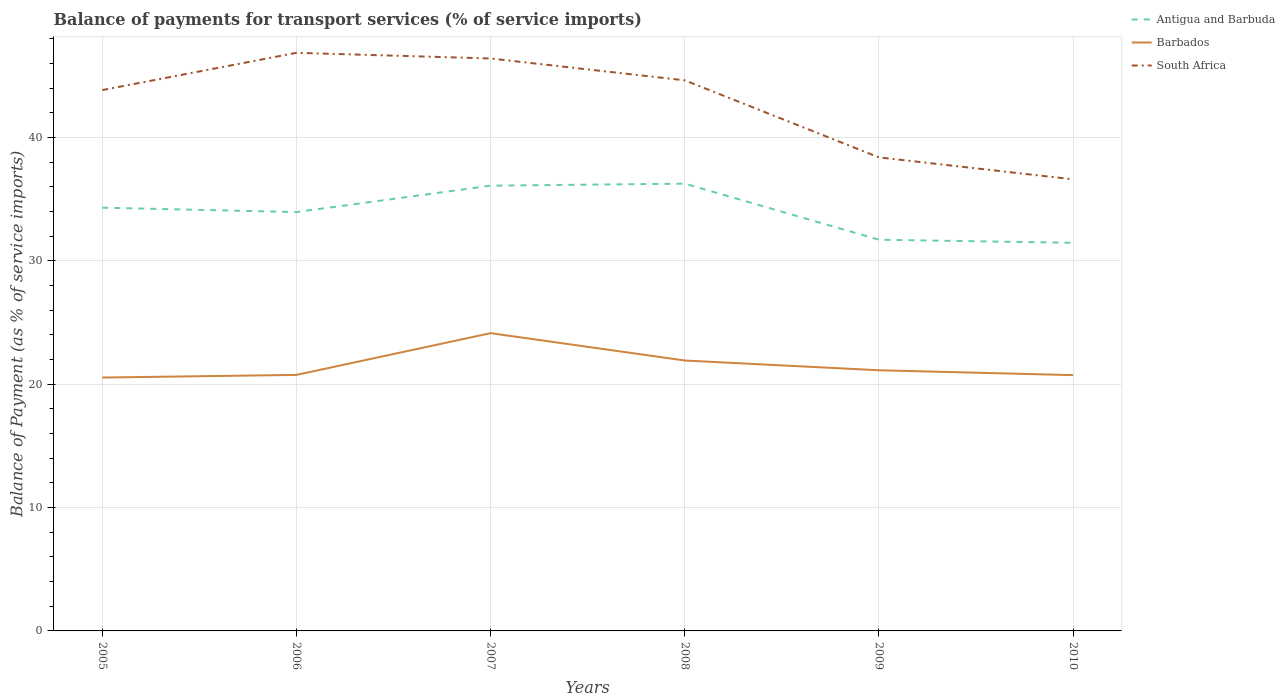Does the line corresponding to Barbados intersect with the line corresponding to South Africa?
Your answer should be compact. No. Across all years, what is the maximum balance of payments for transport services in Antigua and Barbuda?
Provide a succinct answer. 31.47. In which year was the balance of payments for transport services in Antigua and Barbuda maximum?
Your answer should be compact. 2010. What is the total balance of payments for transport services in Antigua and Barbuda in the graph?
Keep it short and to the point. -0.16. What is the difference between the highest and the second highest balance of payments for transport services in Antigua and Barbuda?
Your response must be concise. 4.8. What is the difference between the highest and the lowest balance of payments for transport services in South Africa?
Offer a terse response. 4. Are the values on the major ticks of Y-axis written in scientific E-notation?
Give a very brief answer. No. Does the graph contain grids?
Your answer should be very brief. Yes. Where does the legend appear in the graph?
Offer a terse response. Top right. How many legend labels are there?
Offer a terse response. 3. What is the title of the graph?
Your answer should be compact. Balance of payments for transport services (% of service imports). What is the label or title of the X-axis?
Your answer should be very brief. Years. What is the label or title of the Y-axis?
Offer a very short reply. Balance of Payment (as % of service imports). What is the Balance of Payment (as % of service imports) in Antigua and Barbuda in 2005?
Keep it short and to the point. 34.32. What is the Balance of Payment (as % of service imports) in Barbados in 2005?
Keep it short and to the point. 20.54. What is the Balance of Payment (as % of service imports) in South Africa in 2005?
Provide a short and direct response. 43.85. What is the Balance of Payment (as % of service imports) in Antigua and Barbuda in 2006?
Ensure brevity in your answer.  33.96. What is the Balance of Payment (as % of service imports) of Barbados in 2006?
Offer a very short reply. 20.76. What is the Balance of Payment (as % of service imports) in South Africa in 2006?
Your response must be concise. 46.87. What is the Balance of Payment (as % of service imports) of Antigua and Barbuda in 2007?
Your answer should be very brief. 36.1. What is the Balance of Payment (as % of service imports) of Barbados in 2007?
Make the answer very short. 24.14. What is the Balance of Payment (as % of service imports) in South Africa in 2007?
Make the answer very short. 46.41. What is the Balance of Payment (as % of service imports) in Antigua and Barbuda in 2008?
Your answer should be compact. 36.26. What is the Balance of Payment (as % of service imports) in Barbados in 2008?
Your response must be concise. 21.92. What is the Balance of Payment (as % of service imports) in South Africa in 2008?
Keep it short and to the point. 44.64. What is the Balance of Payment (as % of service imports) of Antigua and Barbuda in 2009?
Provide a succinct answer. 31.72. What is the Balance of Payment (as % of service imports) of Barbados in 2009?
Give a very brief answer. 21.13. What is the Balance of Payment (as % of service imports) in South Africa in 2009?
Give a very brief answer. 38.39. What is the Balance of Payment (as % of service imports) in Antigua and Barbuda in 2010?
Make the answer very short. 31.47. What is the Balance of Payment (as % of service imports) in Barbados in 2010?
Provide a short and direct response. 20.74. What is the Balance of Payment (as % of service imports) in South Africa in 2010?
Give a very brief answer. 36.61. Across all years, what is the maximum Balance of Payment (as % of service imports) of Antigua and Barbuda?
Keep it short and to the point. 36.26. Across all years, what is the maximum Balance of Payment (as % of service imports) of Barbados?
Ensure brevity in your answer.  24.14. Across all years, what is the maximum Balance of Payment (as % of service imports) of South Africa?
Your answer should be compact. 46.87. Across all years, what is the minimum Balance of Payment (as % of service imports) in Antigua and Barbuda?
Provide a short and direct response. 31.47. Across all years, what is the minimum Balance of Payment (as % of service imports) of Barbados?
Ensure brevity in your answer.  20.54. Across all years, what is the minimum Balance of Payment (as % of service imports) of South Africa?
Your answer should be compact. 36.61. What is the total Balance of Payment (as % of service imports) of Antigua and Barbuda in the graph?
Provide a short and direct response. 203.82. What is the total Balance of Payment (as % of service imports) of Barbados in the graph?
Provide a short and direct response. 129.23. What is the total Balance of Payment (as % of service imports) in South Africa in the graph?
Provide a succinct answer. 256.77. What is the difference between the Balance of Payment (as % of service imports) of Antigua and Barbuda in 2005 and that in 2006?
Your answer should be compact. 0.36. What is the difference between the Balance of Payment (as % of service imports) in Barbados in 2005 and that in 2006?
Provide a succinct answer. -0.21. What is the difference between the Balance of Payment (as % of service imports) of South Africa in 2005 and that in 2006?
Your answer should be compact. -3.02. What is the difference between the Balance of Payment (as % of service imports) in Antigua and Barbuda in 2005 and that in 2007?
Provide a succinct answer. -1.78. What is the difference between the Balance of Payment (as % of service imports) of Barbados in 2005 and that in 2007?
Provide a succinct answer. -3.6. What is the difference between the Balance of Payment (as % of service imports) of South Africa in 2005 and that in 2007?
Your response must be concise. -2.56. What is the difference between the Balance of Payment (as % of service imports) in Antigua and Barbuda in 2005 and that in 2008?
Your response must be concise. -1.95. What is the difference between the Balance of Payment (as % of service imports) of Barbados in 2005 and that in 2008?
Keep it short and to the point. -1.38. What is the difference between the Balance of Payment (as % of service imports) in South Africa in 2005 and that in 2008?
Ensure brevity in your answer.  -0.79. What is the difference between the Balance of Payment (as % of service imports) of Antigua and Barbuda in 2005 and that in 2009?
Keep it short and to the point. 2.6. What is the difference between the Balance of Payment (as % of service imports) of Barbados in 2005 and that in 2009?
Your answer should be very brief. -0.59. What is the difference between the Balance of Payment (as % of service imports) in South Africa in 2005 and that in 2009?
Your response must be concise. 5.46. What is the difference between the Balance of Payment (as % of service imports) in Antigua and Barbuda in 2005 and that in 2010?
Ensure brevity in your answer.  2.85. What is the difference between the Balance of Payment (as % of service imports) in Barbados in 2005 and that in 2010?
Offer a terse response. -0.19. What is the difference between the Balance of Payment (as % of service imports) of South Africa in 2005 and that in 2010?
Offer a very short reply. 7.24. What is the difference between the Balance of Payment (as % of service imports) in Antigua and Barbuda in 2006 and that in 2007?
Give a very brief answer. -2.14. What is the difference between the Balance of Payment (as % of service imports) of Barbados in 2006 and that in 2007?
Your answer should be compact. -3.38. What is the difference between the Balance of Payment (as % of service imports) of South Africa in 2006 and that in 2007?
Give a very brief answer. 0.46. What is the difference between the Balance of Payment (as % of service imports) in Antigua and Barbuda in 2006 and that in 2008?
Provide a succinct answer. -2.3. What is the difference between the Balance of Payment (as % of service imports) in Barbados in 2006 and that in 2008?
Offer a terse response. -1.17. What is the difference between the Balance of Payment (as % of service imports) of South Africa in 2006 and that in 2008?
Provide a succinct answer. 2.23. What is the difference between the Balance of Payment (as % of service imports) in Antigua and Barbuda in 2006 and that in 2009?
Give a very brief answer. 2.24. What is the difference between the Balance of Payment (as % of service imports) in Barbados in 2006 and that in 2009?
Offer a terse response. -0.38. What is the difference between the Balance of Payment (as % of service imports) in South Africa in 2006 and that in 2009?
Provide a succinct answer. 8.48. What is the difference between the Balance of Payment (as % of service imports) in Antigua and Barbuda in 2006 and that in 2010?
Provide a succinct answer. 2.49. What is the difference between the Balance of Payment (as % of service imports) in Barbados in 2006 and that in 2010?
Keep it short and to the point. 0.02. What is the difference between the Balance of Payment (as % of service imports) of South Africa in 2006 and that in 2010?
Keep it short and to the point. 10.26. What is the difference between the Balance of Payment (as % of service imports) of Antigua and Barbuda in 2007 and that in 2008?
Provide a succinct answer. -0.16. What is the difference between the Balance of Payment (as % of service imports) of Barbados in 2007 and that in 2008?
Provide a short and direct response. 2.22. What is the difference between the Balance of Payment (as % of service imports) in South Africa in 2007 and that in 2008?
Give a very brief answer. 1.77. What is the difference between the Balance of Payment (as % of service imports) in Antigua and Barbuda in 2007 and that in 2009?
Provide a succinct answer. 4.38. What is the difference between the Balance of Payment (as % of service imports) of Barbados in 2007 and that in 2009?
Your response must be concise. 3.01. What is the difference between the Balance of Payment (as % of service imports) of South Africa in 2007 and that in 2009?
Offer a very short reply. 8.02. What is the difference between the Balance of Payment (as % of service imports) of Antigua and Barbuda in 2007 and that in 2010?
Ensure brevity in your answer.  4.63. What is the difference between the Balance of Payment (as % of service imports) in Barbados in 2007 and that in 2010?
Your answer should be compact. 3.4. What is the difference between the Balance of Payment (as % of service imports) in South Africa in 2007 and that in 2010?
Offer a very short reply. 9.8. What is the difference between the Balance of Payment (as % of service imports) in Antigua and Barbuda in 2008 and that in 2009?
Provide a succinct answer. 4.55. What is the difference between the Balance of Payment (as % of service imports) of Barbados in 2008 and that in 2009?
Keep it short and to the point. 0.79. What is the difference between the Balance of Payment (as % of service imports) in South Africa in 2008 and that in 2009?
Your answer should be very brief. 6.25. What is the difference between the Balance of Payment (as % of service imports) of Antigua and Barbuda in 2008 and that in 2010?
Your answer should be very brief. 4.8. What is the difference between the Balance of Payment (as % of service imports) in Barbados in 2008 and that in 2010?
Your answer should be very brief. 1.19. What is the difference between the Balance of Payment (as % of service imports) of South Africa in 2008 and that in 2010?
Make the answer very short. 8.03. What is the difference between the Balance of Payment (as % of service imports) of Barbados in 2009 and that in 2010?
Your response must be concise. 0.4. What is the difference between the Balance of Payment (as % of service imports) of South Africa in 2009 and that in 2010?
Your response must be concise. 1.78. What is the difference between the Balance of Payment (as % of service imports) of Antigua and Barbuda in 2005 and the Balance of Payment (as % of service imports) of Barbados in 2006?
Provide a succinct answer. 13.56. What is the difference between the Balance of Payment (as % of service imports) of Antigua and Barbuda in 2005 and the Balance of Payment (as % of service imports) of South Africa in 2006?
Offer a terse response. -12.55. What is the difference between the Balance of Payment (as % of service imports) in Barbados in 2005 and the Balance of Payment (as % of service imports) in South Africa in 2006?
Keep it short and to the point. -26.33. What is the difference between the Balance of Payment (as % of service imports) in Antigua and Barbuda in 2005 and the Balance of Payment (as % of service imports) in Barbados in 2007?
Give a very brief answer. 10.17. What is the difference between the Balance of Payment (as % of service imports) in Antigua and Barbuda in 2005 and the Balance of Payment (as % of service imports) in South Africa in 2007?
Offer a very short reply. -12.1. What is the difference between the Balance of Payment (as % of service imports) of Barbados in 2005 and the Balance of Payment (as % of service imports) of South Africa in 2007?
Your answer should be very brief. -25.87. What is the difference between the Balance of Payment (as % of service imports) of Antigua and Barbuda in 2005 and the Balance of Payment (as % of service imports) of Barbados in 2008?
Your answer should be compact. 12.39. What is the difference between the Balance of Payment (as % of service imports) in Antigua and Barbuda in 2005 and the Balance of Payment (as % of service imports) in South Africa in 2008?
Your response must be concise. -10.32. What is the difference between the Balance of Payment (as % of service imports) of Barbados in 2005 and the Balance of Payment (as % of service imports) of South Africa in 2008?
Provide a short and direct response. -24.1. What is the difference between the Balance of Payment (as % of service imports) in Antigua and Barbuda in 2005 and the Balance of Payment (as % of service imports) in Barbados in 2009?
Provide a short and direct response. 13.18. What is the difference between the Balance of Payment (as % of service imports) of Antigua and Barbuda in 2005 and the Balance of Payment (as % of service imports) of South Africa in 2009?
Your answer should be very brief. -4.08. What is the difference between the Balance of Payment (as % of service imports) in Barbados in 2005 and the Balance of Payment (as % of service imports) in South Africa in 2009?
Provide a short and direct response. -17.85. What is the difference between the Balance of Payment (as % of service imports) of Antigua and Barbuda in 2005 and the Balance of Payment (as % of service imports) of Barbados in 2010?
Give a very brief answer. 13.58. What is the difference between the Balance of Payment (as % of service imports) in Antigua and Barbuda in 2005 and the Balance of Payment (as % of service imports) in South Africa in 2010?
Keep it short and to the point. -2.3. What is the difference between the Balance of Payment (as % of service imports) in Barbados in 2005 and the Balance of Payment (as % of service imports) in South Africa in 2010?
Your response must be concise. -16.07. What is the difference between the Balance of Payment (as % of service imports) in Antigua and Barbuda in 2006 and the Balance of Payment (as % of service imports) in Barbados in 2007?
Your answer should be very brief. 9.82. What is the difference between the Balance of Payment (as % of service imports) in Antigua and Barbuda in 2006 and the Balance of Payment (as % of service imports) in South Africa in 2007?
Offer a very short reply. -12.45. What is the difference between the Balance of Payment (as % of service imports) in Barbados in 2006 and the Balance of Payment (as % of service imports) in South Africa in 2007?
Provide a succinct answer. -25.65. What is the difference between the Balance of Payment (as % of service imports) in Antigua and Barbuda in 2006 and the Balance of Payment (as % of service imports) in Barbados in 2008?
Offer a terse response. 12.04. What is the difference between the Balance of Payment (as % of service imports) in Antigua and Barbuda in 2006 and the Balance of Payment (as % of service imports) in South Africa in 2008?
Provide a short and direct response. -10.68. What is the difference between the Balance of Payment (as % of service imports) in Barbados in 2006 and the Balance of Payment (as % of service imports) in South Africa in 2008?
Provide a short and direct response. -23.88. What is the difference between the Balance of Payment (as % of service imports) in Antigua and Barbuda in 2006 and the Balance of Payment (as % of service imports) in Barbados in 2009?
Your answer should be compact. 12.83. What is the difference between the Balance of Payment (as % of service imports) in Antigua and Barbuda in 2006 and the Balance of Payment (as % of service imports) in South Africa in 2009?
Keep it short and to the point. -4.43. What is the difference between the Balance of Payment (as % of service imports) of Barbados in 2006 and the Balance of Payment (as % of service imports) of South Africa in 2009?
Keep it short and to the point. -17.64. What is the difference between the Balance of Payment (as % of service imports) in Antigua and Barbuda in 2006 and the Balance of Payment (as % of service imports) in Barbados in 2010?
Your response must be concise. 13.22. What is the difference between the Balance of Payment (as % of service imports) of Antigua and Barbuda in 2006 and the Balance of Payment (as % of service imports) of South Africa in 2010?
Offer a terse response. -2.65. What is the difference between the Balance of Payment (as % of service imports) of Barbados in 2006 and the Balance of Payment (as % of service imports) of South Africa in 2010?
Provide a short and direct response. -15.86. What is the difference between the Balance of Payment (as % of service imports) of Antigua and Barbuda in 2007 and the Balance of Payment (as % of service imports) of Barbados in 2008?
Your answer should be very brief. 14.18. What is the difference between the Balance of Payment (as % of service imports) in Antigua and Barbuda in 2007 and the Balance of Payment (as % of service imports) in South Africa in 2008?
Make the answer very short. -8.54. What is the difference between the Balance of Payment (as % of service imports) of Barbados in 2007 and the Balance of Payment (as % of service imports) of South Africa in 2008?
Give a very brief answer. -20.5. What is the difference between the Balance of Payment (as % of service imports) of Antigua and Barbuda in 2007 and the Balance of Payment (as % of service imports) of Barbados in 2009?
Ensure brevity in your answer.  14.97. What is the difference between the Balance of Payment (as % of service imports) of Antigua and Barbuda in 2007 and the Balance of Payment (as % of service imports) of South Africa in 2009?
Offer a terse response. -2.29. What is the difference between the Balance of Payment (as % of service imports) of Barbados in 2007 and the Balance of Payment (as % of service imports) of South Africa in 2009?
Your answer should be compact. -14.25. What is the difference between the Balance of Payment (as % of service imports) of Antigua and Barbuda in 2007 and the Balance of Payment (as % of service imports) of Barbados in 2010?
Your answer should be very brief. 15.36. What is the difference between the Balance of Payment (as % of service imports) in Antigua and Barbuda in 2007 and the Balance of Payment (as % of service imports) in South Africa in 2010?
Provide a short and direct response. -0.51. What is the difference between the Balance of Payment (as % of service imports) in Barbados in 2007 and the Balance of Payment (as % of service imports) in South Africa in 2010?
Make the answer very short. -12.47. What is the difference between the Balance of Payment (as % of service imports) of Antigua and Barbuda in 2008 and the Balance of Payment (as % of service imports) of Barbados in 2009?
Provide a succinct answer. 15.13. What is the difference between the Balance of Payment (as % of service imports) of Antigua and Barbuda in 2008 and the Balance of Payment (as % of service imports) of South Africa in 2009?
Provide a succinct answer. -2.13. What is the difference between the Balance of Payment (as % of service imports) of Barbados in 2008 and the Balance of Payment (as % of service imports) of South Africa in 2009?
Provide a succinct answer. -16.47. What is the difference between the Balance of Payment (as % of service imports) of Antigua and Barbuda in 2008 and the Balance of Payment (as % of service imports) of Barbados in 2010?
Offer a very short reply. 15.52. What is the difference between the Balance of Payment (as % of service imports) in Antigua and Barbuda in 2008 and the Balance of Payment (as % of service imports) in South Africa in 2010?
Offer a very short reply. -0.35. What is the difference between the Balance of Payment (as % of service imports) in Barbados in 2008 and the Balance of Payment (as % of service imports) in South Africa in 2010?
Ensure brevity in your answer.  -14.69. What is the difference between the Balance of Payment (as % of service imports) in Antigua and Barbuda in 2009 and the Balance of Payment (as % of service imports) in Barbados in 2010?
Offer a very short reply. 10.98. What is the difference between the Balance of Payment (as % of service imports) in Antigua and Barbuda in 2009 and the Balance of Payment (as % of service imports) in South Africa in 2010?
Your response must be concise. -4.9. What is the difference between the Balance of Payment (as % of service imports) in Barbados in 2009 and the Balance of Payment (as % of service imports) in South Africa in 2010?
Give a very brief answer. -15.48. What is the average Balance of Payment (as % of service imports) of Antigua and Barbuda per year?
Your response must be concise. 33.97. What is the average Balance of Payment (as % of service imports) of Barbados per year?
Provide a short and direct response. 21.54. What is the average Balance of Payment (as % of service imports) in South Africa per year?
Your response must be concise. 42.8. In the year 2005, what is the difference between the Balance of Payment (as % of service imports) of Antigua and Barbuda and Balance of Payment (as % of service imports) of Barbados?
Your answer should be very brief. 13.77. In the year 2005, what is the difference between the Balance of Payment (as % of service imports) of Antigua and Barbuda and Balance of Payment (as % of service imports) of South Africa?
Give a very brief answer. -9.53. In the year 2005, what is the difference between the Balance of Payment (as % of service imports) of Barbados and Balance of Payment (as % of service imports) of South Africa?
Your answer should be very brief. -23.31. In the year 2006, what is the difference between the Balance of Payment (as % of service imports) in Antigua and Barbuda and Balance of Payment (as % of service imports) in Barbados?
Your response must be concise. 13.2. In the year 2006, what is the difference between the Balance of Payment (as % of service imports) of Antigua and Barbuda and Balance of Payment (as % of service imports) of South Africa?
Keep it short and to the point. -12.91. In the year 2006, what is the difference between the Balance of Payment (as % of service imports) in Barbados and Balance of Payment (as % of service imports) in South Africa?
Offer a very short reply. -26.11. In the year 2007, what is the difference between the Balance of Payment (as % of service imports) of Antigua and Barbuda and Balance of Payment (as % of service imports) of Barbados?
Make the answer very short. 11.96. In the year 2007, what is the difference between the Balance of Payment (as % of service imports) of Antigua and Barbuda and Balance of Payment (as % of service imports) of South Africa?
Keep it short and to the point. -10.31. In the year 2007, what is the difference between the Balance of Payment (as % of service imports) of Barbados and Balance of Payment (as % of service imports) of South Africa?
Ensure brevity in your answer.  -22.27. In the year 2008, what is the difference between the Balance of Payment (as % of service imports) of Antigua and Barbuda and Balance of Payment (as % of service imports) of Barbados?
Your answer should be compact. 14.34. In the year 2008, what is the difference between the Balance of Payment (as % of service imports) of Antigua and Barbuda and Balance of Payment (as % of service imports) of South Africa?
Make the answer very short. -8.38. In the year 2008, what is the difference between the Balance of Payment (as % of service imports) in Barbados and Balance of Payment (as % of service imports) in South Africa?
Offer a terse response. -22.72. In the year 2009, what is the difference between the Balance of Payment (as % of service imports) in Antigua and Barbuda and Balance of Payment (as % of service imports) in Barbados?
Ensure brevity in your answer.  10.58. In the year 2009, what is the difference between the Balance of Payment (as % of service imports) of Antigua and Barbuda and Balance of Payment (as % of service imports) of South Africa?
Make the answer very short. -6.68. In the year 2009, what is the difference between the Balance of Payment (as % of service imports) of Barbados and Balance of Payment (as % of service imports) of South Africa?
Keep it short and to the point. -17.26. In the year 2010, what is the difference between the Balance of Payment (as % of service imports) of Antigua and Barbuda and Balance of Payment (as % of service imports) of Barbados?
Offer a terse response. 10.73. In the year 2010, what is the difference between the Balance of Payment (as % of service imports) in Antigua and Barbuda and Balance of Payment (as % of service imports) in South Africa?
Your answer should be very brief. -5.15. In the year 2010, what is the difference between the Balance of Payment (as % of service imports) of Barbados and Balance of Payment (as % of service imports) of South Africa?
Offer a very short reply. -15.88. What is the ratio of the Balance of Payment (as % of service imports) of Antigua and Barbuda in 2005 to that in 2006?
Keep it short and to the point. 1.01. What is the ratio of the Balance of Payment (as % of service imports) in Barbados in 2005 to that in 2006?
Your answer should be compact. 0.99. What is the ratio of the Balance of Payment (as % of service imports) of South Africa in 2005 to that in 2006?
Give a very brief answer. 0.94. What is the ratio of the Balance of Payment (as % of service imports) of Antigua and Barbuda in 2005 to that in 2007?
Ensure brevity in your answer.  0.95. What is the ratio of the Balance of Payment (as % of service imports) in Barbados in 2005 to that in 2007?
Your response must be concise. 0.85. What is the ratio of the Balance of Payment (as % of service imports) of South Africa in 2005 to that in 2007?
Your answer should be very brief. 0.94. What is the ratio of the Balance of Payment (as % of service imports) in Antigua and Barbuda in 2005 to that in 2008?
Keep it short and to the point. 0.95. What is the ratio of the Balance of Payment (as % of service imports) of Barbados in 2005 to that in 2008?
Provide a short and direct response. 0.94. What is the ratio of the Balance of Payment (as % of service imports) in South Africa in 2005 to that in 2008?
Ensure brevity in your answer.  0.98. What is the ratio of the Balance of Payment (as % of service imports) in Antigua and Barbuda in 2005 to that in 2009?
Keep it short and to the point. 1.08. What is the ratio of the Balance of Payment (as % of service imports) of Barbados in 2005 to that in 2009?
Keep it short and to the point. 0.97. What is the ratio of the Balance of Payment (as % of service imports) in South Africa in 2005 to that in 2009?
Provide a short and direct response. 1.14. What is the ratio of the Balance of Payment (as % of service imports) in Antigua and Barbuda in 2005 to that in 2010?
Ensure brevity in your answer.  1.09. What is the ratio of the Balance of Payment (as % of service imports) of Barbados in 2005 to that in 2010?
Your response must be concise. 0.99. What is the ratio of the Balance of Payment (as % of service imports) of South Africa in 2005 to that in 2010?
Your response must be concise. 1.2. What is the ratio of the Balance of Payment (as % of service imports) in Antigua and Barbuda in 2006 to that in 2007?
Your response must be concise. 0.94. What is the ratio of the Balance of Payment (as % of service imports) in Barbados in 2006 to that in 2007?
Keep it short and to the point. 0.86. What is the ratio of the Balance of Payment (as % of service imports) in South Africa in 2006 to that in 2007?
Offer a terse response. 1.01. What is the ratio of the Balance of Payment (as % of service imports) of Antigua and Barbuda in 2006 to that in 2008?
Offer a very short reply. 0.94. What is the ratio of the Balance of Payment (as % of service imports) of Barbados in 2006 to that in 2008?
Your answer should be compact. 0.95. What is the ratio of the Balance of Payment (as % of service imports) in South Africa in 2006 to that in 2008?
Offer a very short reply. 1.05. What is the ratio of the Balance of Payment (as % of service imports) in Antigua and Barbuda in 2006 to that in 2009?
Offer a terse response. 1.07. What is the ratio of the Balance of Payment (as % of service imports) in Barbados in 2006 to that in 2009?
Ensure brevity in your answer.  0.98. What is the ratio of the Balance of Payment (as % of service imports) in South Africa in 2006 to that in 2009?
Your answer should be compact. 1.22. What is the ratio of the Balance of Payment (as % of service imports) in Antigua and Barbuda in 2006 to that in 2010?
Offer a very short reply. 1.08. What is the ratio of the Balance of Payment (as % of service imports) in South Africa in 2006 to that in 2010?
Offer a very short reply. 1.28. What is the ratio of the Balance of Payment (as % of service imports) of Barbados in 2007 to that in 2008?
Keep it short and to the point. 1.1. What is the ratio of the Balance of Payment (as % of service imports) in South Africa in 2007 to that in 2008?
Offer a very short reply. 1.04. What is the ratio of the Balance of Payment (as % of service imports) of Antigua and Barbuda in 2007 to that in 2009?
Offer a terse response. 1.14. What is the ratio of the Balance of Payment (as % of service imports) in Barbados in 2007 to that in 2009?
Give a very brief answer. 1.14. What is the ratio of the Balance of Payment (as % of service imports) in South Africa in 2007 to that in 2009?
Your answer should be very brief. 1.21. What is the ratio of the Balance of Payment (as % of service imports) of Antigua and Barbuda in 2007 to that in 2010?
Provide a succinct answer. 1.15. What is the ratio of the Balance of Payment (as % of service imports) in Barbados in 2007 to that in 2010?
Offer a very short reply. 1.16. What is the ratio of the Balance of Payment (as % of service imports) of South Africa in 2007 to that in 2010?
Keep it short and to the point. 1.27. What is the ratio of the Balance of Payment (as % of service imports) of Antigua and Barbuda in 2008 to that in 2009?
Keep it short and to the point. 1.14. What is the ratio of the Balance of Payment (as % of service imports) of Barbados in 2008 to that in 2009?
Offer a very short reply. 1.04. What is the ratio of the Balance of Payment (as % of service imports) in South Africa in 2008 to that in 2009?
Give a very brief answer. 1.16. What is the ratio of the Balance of Payment (as % of service imports) in Antigua and Barbuda in 2008 to that in 2010?
Provide a succinct answer. 1.15. What is the ratio of the Balance of Payment (as % of service imports) in Barbados in 2008 to that in 2010?
Keep it short and to the point. 1.06. What is the ratio of the Balance of Payment (as % of service imports) of South Africa in 2008 to that in 2010?
Your answer should be compact. 1.22. What is the ratio of the Balance of Payment (as % of service imports) of Antigua and Barbuda in 2009 to that in 2010?
Your answer should be compact. 1.01. What is the ratio of the Balance of Payment (as % of service imports) in Barbados in 2009 to that in 2010?
Provide a succinct answer. 1.02. What is the ratio of the Balance of Payment (as % of service imports) in South Africa in 2009 to that in 2010?
Your answer should be compact. 1.05. What is the difference between the highest and the second highest Balance of Payment (as % of service imports) of Antigua and Barbuda?
Ensure brevity in your answer.  0.16. What is the difference between the highest and the second highest Balance of Payment (as % of service imports) in Barbados?
Provide a short and direct response. 2.22. What is the difference between the highest and the second highest Balance of Payment (as % of service imports) of South Africa?
Offer a very short reply. 0.46. What is the difference between the highest and the lowest Balance of Payment (as % of service imports) of Antigua and Barbuda?
Offer a very short reply. 4.8. What is the difference between the highest and the lowest Balance of Payment (as % of service imports) in Barbados?
Offer a very short reply. 3.6. What is the difference between the highest and the lowest Balance of Payment (as % of service imports) of South Africa?
Your answer should be very brief. 10.26. 